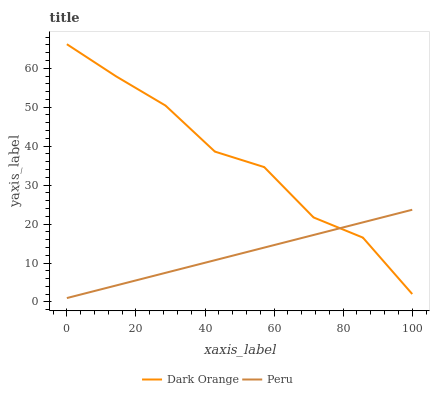Does Peru have the minimum area under the curve?
Answer yes or no. Yes. Does Dark Orange have the maximum area under the curve?
Answer yes or no. Yes. Does Peru have the maximum area under the curve?
Answer yes or no. No. Is Peru the smoothest?
Answer yes or no. Yes. Is Dark Orange the roughest?
Answer yes or no. Yes. Is Peru the roughest?
Answer yes or no. No. Does Peru have the lowest value?
Answer yes or no. Yes. Does Dark Orange have the highest value?
Answer yes or no. Yes. Does Peru have the highest value?
Answer yes or no. No. Does Peru intersect Dark Orange?
Answer yes or no. Yes. Is Peru less than Dark Orange?
Answer yes or no. No. Is Peru greater than Dark Orange?
Answer yes or no. No. 